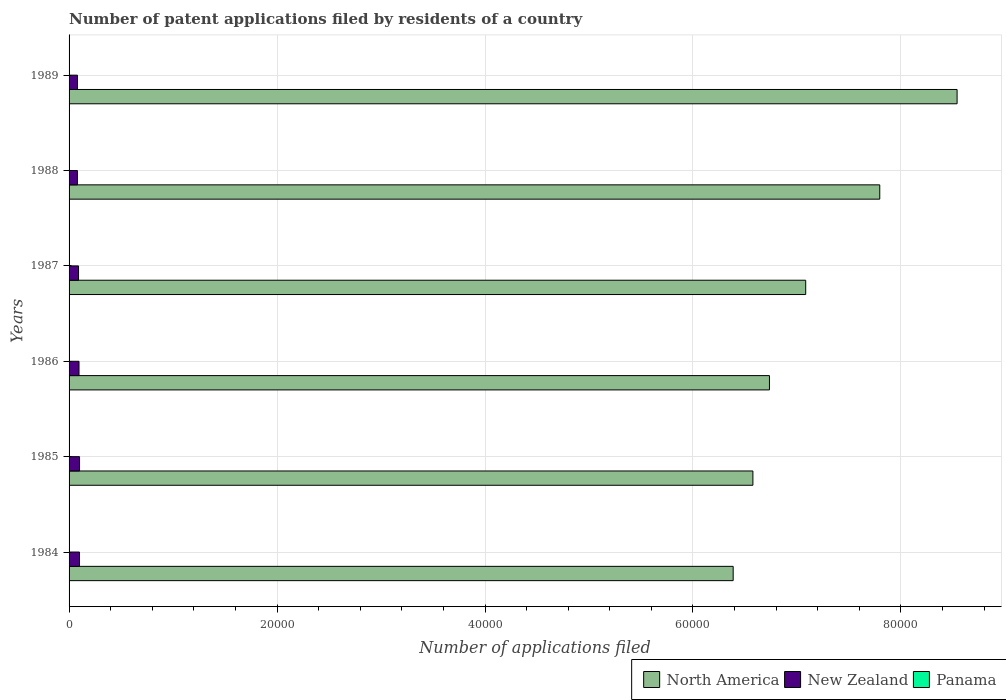Are the number of bars per tick equal to the number of legend labels?
Give a very brief answer. Yes. How many bars are there on the 5th tick from the top?
Your answer should be very brief. 3. How many bars are there on the 3rd tick from the bottom?
Provide a short and direct response. 3. What is the number of applications filed in New Zealand in 1986?
Offer a terse response. 957. Across all years, what is the maximum number of applications filed in New Zealand?
Make the answer very short. 1008. Across all years, what is the minimum number of applications filed in New Zealand?
Provide a short and direct response. 803. In which year was the number of applications filed in North America maximum?
Provide a succinct answer. 1989. In which year was the number of applications filed in North America minimum?
Keep it short and to the point. 1984. What is the total number of applications filed in North America in the graph?
Your answer should be very brief. 4.31e+05. What is the difference between the number of applications filed in North America in 1984 and that in 1986?
Your answer should be compact. -3489. What is the difference between the number of applications filed in North America in 1987 and the number of applications filed in New Zealand in 1986?
Your answer should be compact. 6.99e+04. What is the average number of applications filed in North America per year?
Provide a succinct answer. 7.19e+04. In the year 1986, what is the difference between the number of applications filed in New Zealand and number of applications filed in North America?
Offer a very short reply. -6.64e+04. What is the ratio of the number of applications filed in Panama in 1985 to that in 1988?
Make the answer very short. 1.56. Is the number of applications filed in North America in 1986 less than that in 1988?
Provide a succinct answer. Yes. Is the difference between the number of applications filed in New Zealand in 1986 and 1987 greater than the difference between the number of applications filed in North America in 1986 and 1987?
Provide a short and direct response. Yes. What is the difference between the highest and the second highest number of applications filed in New Zealand?
Keep it short and to the point. 7. What is the difference between the highest and the lowest number of applications filed in Panama?
Your response must be concise. 12. What does the 1st bar from the top in 1986 represents?
Provide a succinct answer. Panama. What does the 3rd bar from the bottom in 1988 represents?
Make the answer very short. Panama. Is it the case that in every year, the sum of the number of applications filed in New Zealand and number of applications filed in Panama is greater than the number of applications filed in North America?
Your answer should be very brief. No. How many bars are there?
Offer a terse response. 18. Are all the bars in the graph horizontal?
Your answer should be very brief. Yes. How many years are there in the graph?
Ensure brevity in your answer.  6. Does the graph contain grids?
Your response must be concise. Yes. Where does the legend appear in the graph?
Your response must be concise. Bottom right. How many legend labels are there?
Give a very brief answer. 3. What is the title of the graph?
Offer a terse response. Number of patent applications filed by residents of a country. Does "Benin" appear as one of the legend labels in the graph?
Your answer should be compact. No. What is the label or title of the X-axis?
Offer a very short reply. Number of applications filed. What is the Number of applications filed in North America in 1984?
Offer a very short reply. 6.39e+04. What is the Number of applications filed in New Zealand in 1984?
Keep it short and to the point. 1001. What is the Number of applications filed of North America in 1985?
Offer a terse response. 6.58e+04. What is the Number of applications filed in New Zealand in 1985?
Make the answer very short. 1008. What is the Number of applications filed in Panama in 1985?
Your answer should be very brief. 14. What is the Number of applications filed in North America in 1986?
Your answer should be compact. 6.74e+04. What is the Number of applications filed of New Zealand in 1986?
Offer a very short reply. 957. What is the Number of applications filed of Panama in 1986?
Offer a very short reply. 11. What is the Number of applications filed of North America in 1987?
Your answer should be compact. 7.08e+04. What is the Number of applications filed of New Zealand in 1987?
Provide a succinct answer. 912. What is the Number of applications filed in North America in 1988?
Provide a succinct answer. 7.80e+04. What is the Number of applications filed in New Zealand in 1988?
Provide a succinct answer. 803. What is the Number of applications filed of Panama in 1988?
Ensure brevity in your answer.  9. What is the Number of applications filed of North America in 1989?
Provide a short and direct response. 8.54e+04. What is the Number of applications filed of New Zealand in 1989?
Make the answer very short. 807. Across all years, what is the maximum Number of applications filed of North America?
Provide a succinct answer. 8.54e+04. Across all years, what is the maximum Number of applications filed of New Zealand?
Offer a terse response. 1008. Across all years, what is the maximum Number of applications filed in Panama?
Your answer should be compact. 15. Across all years, what is the minimum Number of applications filed in North America?
Keep it short and to the point. 6.39e+04. Across all years, what is the minimum Number of applications filed in New Zealand?
Ensure brevity in your answer.  803. Across all years, what is the minimum Number of applications filed in Panama?
Your answer should be compact. 3. What is the total Number of applications filed of North America in the graph?
Make the answer very short. 4.31e+05. What is the total Number of applications filed of New Zealand in the graph?
Your answer should be very brief. 5488. What is the total Number of applications filed of Panama in the graph?
Offer a very short reply. 58. What is the difference between the Number of applications filed in North America in 1984 and that in 1985?
Ensure brevity in your answer.  -1898. What is the difference between the Number of applications filed in New Zealand in 1984 and that in 1985?
Keep it short and to the point. -7. What is the difference between the Number of applications filed in Panama in 1984 and that in 1985?
Provide a short and direct response. 1. What is the difference between the Number of applications filed in North America in 1984 and that in 1986?
Provide a short and direct response. -3489. What is the difference between the Number of applications filed in New Zealand in 1984 and that in 1986?
Your response must be concise. 44. What is the difference between the Number of applications filed of Panama in 1984 and that in 1986?
Ensure brevity in your answer.  4. What is the difference between the Number of applications filed of North America in 1984 and that in 1987?
Your answer should be compact. -6975. What is the difference between the Number of applications filed in New Zealand in 1984 and that in 1987?
Keep it short and to the point. 89. What is the difference between the Number of applications filed in Panama in 1984 and that in 1987?
Make the answer very short. 12. What is the difference between the Number of applications filed of North America in 1984 and that in 1988?
Provide a short and direct response. -1.41e+04. What is the difference between the Number of applications filed of New Zealand in 1984 and that in 1988?
Provide a succinct answer. 198. What is the difference between the Number of applications filed in Panama in 1984 and that in 1988?
Give a very brief answer. 6. What is the difference between the Number of applications filed in North America in 1984 and that in 1989?
Your answer should be compact. -2.15e+04. What is the difference between the Number of applications filed of New Zealand in 1984 and that in 1989?
Provide a short and direct response. 194. What is the difference between the Number of applications filed of Panama in 1984 and that in 1989?
Your answer should be compact. 9. What is the difference between the Number of applications filed in North America in 1985 and that in 1986?
Keep it short and to the point. -1591. What is the difference between the Number of applications filed of New Zealand in 1985 and that in 1986?
Make the answer very short. 51. What is the difference between the Number of applications filed of North America in 1985 and that in 1987?
Your response must be concise. -5077. What is the difference between the Number of applications filed in New Zealand in 1985 and that in 1987?
Make the answer very short. 96. What is the difference between the Number of applications filed in Panama in 1985 and that in 1987?
Provide a short and direct response. 11. What is the difference between the Number of applications filed in North America in 1985 and that in 1988?
Your response must be concise. -1.22e+04. What is the difference between the Number of applications filed in New Zealand in 1985 and that in 1988?
Ensure brevity in your answer.  205. What is the difference between the Number of applications filed of North America in 1985 and that in 1989?
Your answer should be compact. -1.96e+04. What is the difference between the Number of applications filed of New Zealand in 1985 and that in 1989?
Your answer should be compact. 201. What is the difference between the Number of applications filed of North America in 1986 and that in 1987?
Ensure brevity in your answer.  -3486. What is the difference between the Number of applications filed of New Zealand in 1986 and that in 1987?
Make the answer very short. 45. What is the difference between the Number of applications filed in North America in 1986 and that in 1988?
Ensure brevity in your answer.  -1.06e+04. What is the difference between the Number of applications filed in New Zealand in 1986 and that in 1988?
Keep it short and to the point. 154. What is the difference between the Number of applications filed in Panama in 1986 and that in 1988?
Offer a terse response. 2. What is the difference between the Number of applications filed in North America in 1986 and that in 1989?
Offer a very short reply. -1.80e+04. What is the difference between the Number of applications filed of New Zealand in 1986 and that in 1989?
Your answer should be very brief. 150. What is the difference between the Number of applications filed of North America in 1987 and that in 1988?
Keep it short and to the point. -7122. What is the difference between the Number of applications filed in New Zealand in 1987 and that in 1988?
Keep it short and to the point. 109. What is the difference between the Number of applications filed in North America in 1987 and that in 1989?
Your response must be concise. -1.46e+04. What is the difference between the Number of applications filed in New Zealand in 1987 and that in 1989?
Give a very brief answer. 105. What is the difference between the Number of applications filed of Panama in 1987 and that in 1989?
Ensure brevity in your answer.  -3. What is the difference between the Number of applications filed in North America in 1988 and that in 1989?
Your answer should be compact. -7437. What is the difference between the Number of applications filed in Panama in 1988 and that in 1989?
Keep it short and to the point. 3. What is the difference between the Number of applications filed in North America in 1984 and the Number of applications filed in New Zealand in 1985?
Give a very brief answer. 6.29e+04. What is the difference between the Number of applications filed in North America in 1984 and the Number of applications filed in Panama in 1985?
Provide a succinct answer. 6.39e+04. What is the difference between the Number of applications filed of New Zealand in 1984 and the Number of applications filed of Panama in 1985?
Your response must be concise. 987. What is the difference between the Number of applications filed of North America in 1984 and the Number of applications filed of New Zealand in 1986?
Offer a very short reply. 6.29e+04. What is the difference between the Number of applications filed of North America in 1984 and the Number of applications filed of Panama in 1986?
Your answer should be compact. 6.39e+04. What is the difference between the Number of applications filed in New Zealand in 1984 and the Number of applications filed in Panama in 1986?
Give a very brief answer. 990. What is the difference between the Number of applications filed in North America in 1984 and the Number of applications filed in New Zealand in 1987?
Your answer should be compact. 6.30e+04. What is the difference between the Number of applications filed in North America in 1984 and the Number of applications filed in Panama in 1987?
Your answer should be very brief. 6.39e+04. What is the difference between the Number of applications filed of New Zealand in 1984 and the Number of applications filed of Panama in 1987?
Your answer should be very brief. 998. What is the difference between the Number of applications filed in North America in 1984 and the Number of applications filed in New Zealand in 1988?
Provide a short and direct response. 6.31e+04. What is the difference between the Number of applications filed in North America in 1984 and the Number of applications filed in Panama in 1988?
Make the answer very short. 6.39e+04. What is the difference between the Number of applications filed of New Zealand in 1984 and the Number of applications filed of Panama in 1988?
Provide a succinct answer. 992. What is the difference between the Number of applications filed of North America in 1984 and the Number of applications filed of New Zealand in 1989?
Your answer should be very brief. 6.31e+04. What is the difference between the Number of applications filed in North America in 1984 and the Number of applications filed in Panama in 1989?
Ensure brevity in your answer.  6.39e+04. What is the difference between the Number of applications filed in New Zealand in 1984 and the Number of applications filed in Panama in 1989?
Your answer should be compact. 995. What is the difference between the Number of applications filed of North America in 1985 and the Number of applications filed of New Zealand in 1986?
Keep it short and to the point. 6.48e+04. What is the difference between the Number of applications filed in North America in 1985 and the Number of applications filed in Panama in 1986?
Offer a very short reply. 6.58e+04. What is the difference between the Number of applications filed of New Zealand in 1985 and the Number of applications filed of Panama in 1986?
Make the answer very short. 997. What is the difference between the Number of applications filed of North America in 1985 and the Number of applications filed of New Zealand in 1987?
Your answer should be compact. 6.49e+04. What is the difference between the Number of applications filed in North America in 1985 and the Number of applications filed in Panama in 1987?
Provide a short and direct response. 6.58e+04. What is the difference between the Number of applications filed of New Zealand in 1985 and the Number of applications filed of Panama in 1987?
Keep it short and to the point. 1005. What is the difference between the Number of applications filed of North America in 1985 and the Number of applications filed of New Zealand in 1988?
Ensure brevity in your answer.  6.50e+04. What is the difference between the Number of applications filed of North America in 1985 and the Number of applications filed of Panama in 1988?
Offer a terse response. 6.58e+04. What is the difference between the Number of applications filed in New Zealand in 1985 and the Number of applications filed in Panama in 1988?
Provide a short and direct response. 999. What is the difference between the Number of applications filed in North America in 1985 and the Number of applications filed in New Zealand in 1989?
Ensure brevity in your answer.  6.50e+04. What is the difference between the Number of applications filed in North America in 1985 and the Number of applications filed in Panama in 1989?
Keep it short and to the point. 6.58e+04. What is the difference between the Number of applications filed of New Zealand in 1985 and the Number of applications filed of Panama in 1989?
Keep it short and to the point. 1002. What is the difference between the Number of applications filed in North America in 1986 and the Number of applications filed in New Zealand in 1987?
Provide a short and direct response. 6.64e+04. What is the difference between the Number of applications filed in North America in 1986 and the Number of applications filed in Panama in 1987?
Offer a terse response. 6.74e+04. What is the difference between the Number of applications filed in New Zealand in 1986 and the Number of applications filed in Panama in 1987?
Offer a terse response. 954. What is the difference between the Number of applications filed of North America in 1986 and the Number of applications filed of New Zealand in 1988?
Offer a very short reply. 6.66e+04. What is the difference between the Number of applications filed of North America in 1986 and the Number of applications filed of Panama in 1988?
Your answer should be compact. 6.73e+04. What is the difference between the Number of applications filed in New Zealand in 1986 and the Number of applications filed in Panama in 1988?
Provide a succinct answer. 948. What is the difference between the Number of applications filed of North America in 1986 and the Number of applications filed of New Zealand in 1989?
Give a very brief answer. 6.65e+04. What is the difference between the Number of applications filed of North America in 1986 and the Number of applications filed of Panama in 1989?
Your answer should be very brief. 6.74e+04. What is the difference between the Number of applications filed of New Zealand in 1986 and the Number of applications filed of Panama in 1989?
Make the answer very short. 951. What is the difference between the Number of applications filed in North America in 1987 and the Number of applications filed in New Zealand in 1988?
Your answer should be very brief. 7.00e+04. What is the difference between the Number of applications filed of North America in 1987 and the Number of applications filed of Panama in 1988?
Provide a succinct answer. 7.08e+04. What is the difference between the Number of applications filed of New Zealand in 1987 and the Number of applications filed of Panama in 1988?
Provide a succinct answer. 903. What is the difference between the Number of applications filed in North America in 1987 and the Number of applications filed in New Zealand in 1989?
Your response must be concise. 7.00e+04. What is the difference between the Number of applications filed of North America in 1987 and the Number of applications filed of Panama in 1989?
Offer a terse response. 7.08e+04. What is the difference between the Number of applications filed in New Zealand in 1987 and the Number of applications filed in Panama in 1989?
Your answer should be very brief. 906. What is the difference between the Number of applications filed in North America in 1988 and the Number of applications filed in New Zealand in 1989?
Give a very brief answer. 7.72e+04. What is the difference between the Number of applications filed in North America in 1988 and the Number of applications filed in Panama in 1989?
Your response must be concise. 7.80e+04. What is the difference between the Number of applications filed of New Zealand in 1988 and the Number of applications filed of Panama in 1989?
Provide a succinct answer. 797. What is the average Number of applications filed of North America per year?
Make the answer very short. 7.19e+04. What is the average Number of applications filed in New Zealand per year?
Give a very brief answer. 914.67. What is the average Number of applications filed in Panama per year?
Keep it short and to the point. 9.67. In the year 1984, what is the difference between the Number of applications filed of North America and Number of applications filed of New Zealand?
Provide a succinct answer. 6.29e+04. In the year 1984, what is the difference between the Number of applications filed in North America and Number of applications filed in Panama?
Give a very brief answer. 6.39e+04. In the year 1984, what is the difference between the Number of applications filed in New Zealand and Number of applications filed in Panama?
Your response must be concise. 986. In the year 1985, what is the difference between the Number of applications filed of North America and Number of applications filed of New Zealand?
Provide a short and direct response. 6.48e+04. In the year 1985, what is the difference between the Number of applications filed in North America and Number of applications filed in Panama?
Offer a terse response. 6.58e+04. In the year 1985, what is the difference between the Number of applications filed in New Zealand and Number of applications filed in Panama?
Give a very brief answer. 994. In the year 1986, what is the difference between the Number of applications filed in North America and Number of applications filed in New Zealand?
Your response must be concise. 6.64e+04. In the year 1986, what is the difference between the Number of applications filed in North America and Number of applications filed in Panama?
Provide a short and direct response. 6.73e+04. In the year 1986, what is the difference between the Number of applications filed in New Zealand and Number of applications filed in Panama?
Your answer should be compact. 946. In the year 1987, what is the difference between the Number of applications filed of North America and Number of applications filed of New Zealand?
Make the answer very short. 6.99e+04. In the year 1987, what is the difference between the Number of applications filed of North America and Number of applications filed of Panama?
Offer a very short reply. 7.08e+04. In the year 1987, what is the difference between the Number of applications filed in New Zealand and Number of applications filed in Panama?
Provide a short and direct response. 909. In the year 1988, what is the difference between the Number of applications filed in North America and Number of applications filed in New Zealand?
Give a very brief answer. 7.72e+04. In the year 1988, what is the difference between the Number of applications filed in North America and Number of applications filed in Panama?
Provide a short and direct response. 7.80e+04. In the year 1988, what is the difference between the Number of applications filed of New Zealand and Number of applications filed of Panama?
Your answer should be very brief. 794. In the year 1989, what is the difference between the Number of applications filed in North America and Number of applications filed in New Zealand?
Give a very brief answer. 8.46e+04. In the year 1989, what is the difference between the Number of applications filed of North America and Number of applications filed of Panama?
Provide a succinct answer. 8.54e+04. In the year 1989, what is the difference between the Number of applications filed in New Zealand and Number of applications filed in Panama?
Offer a very short reply. 801. What is the ratio of the Number of applications filed of North America in 1984 to that in 1985?
Provide a succinct answer. 0.97. What is the ratio of the Number of applications filed in New Zealand in 1984 to that in 1985?
Provide a short and direct response. 0.99. What is the ratio of the Number of applications filed in Panama in 1984 to that in 1985?
Your answer should be very brief. 1.07. What is the ratio of the Number of applications filed of North America in 1984 to that in 1986?
Keep it short and to the point. 0.95. What is the ratio of the Number of applications filed of New Zealand in 1984 to that in 1986?
Give a very brief answer. 1.05. What is the ratio of the Number of applications filed of Panama in 1984 to that in 1986?
Your response must be concise. 1.36. What is the ratio of the Number of applications filed of North America in 1984 to that in 1987?
Provide a short and direct response. 0.9. What is the ratio of the Number of applications filed in New Zealand in 1984 to that in 1987?
Provide a succinct answer. 1.1. What is the ratio of the Number of applications filed in Panama in 1984 to that in 1987?
Ensure brevity in your answer.  5. What is the ratio of the Number of applications filed in North America in 1984 to that in 1988?
Keep it short and to the point. 0.82. What is the ratio of the Number of applications filed in New Zealand in 1984 to that in 1988?
Offer a very short reply. 1.25. What is the ratio of the Number of applications filed in North America in 1984 to that in 1989?
Make the answer very short. 0.75. What is the ratio of the Number of applications filed in New Zealand in 1984 to that in 1989?
Your response must be concise. 1.24. What is the ratio of the Number of applications filed in Panama in 1984 to that in 1989?
Provide a succinct answer. 2.5. What is the ratio of the Number of applications filed of North America in 1985 to that in 1986?
Your answer should be very brief. 0.98. What is the ratio of the Number of applications filed of New Zealand in 1985 to that in 1986?
Offer a very short reply. 1.05. What is the ratio of the Number of applications filed in Panama in 1985 to that in 1986?
Make the answer very short. 1.27. What is the ratio of the Number of applications filed in North America in 1985 to that in 1987?
Provide a succinct answer. 0.93. What is the ratio of the Number of applications filed in New Zealand in 1985 to that in 1987?
Offer a very short reply. 1.11. What is the ratio of the Number of applications filed in Panama in 1985 to that in 1987?
Provide a short and direct response. 4.67. What is the ratio of the Number of applications filed in North America in 1985 to that in 1988?
Keep it short and to the point. 0.84. What is the ratio of the Number of applications filed of New Zealand in 1985 to that in 1988?
Give a very brief answer. 1.26. What is the ratio of the Number of applications filed in Panama in 1985 to that in 1988?
Offer a very short reply. 1.56. What is the ratio of the Number of applications filed of North America in 1985 to that in 1989?
Provide a short and direct response. 0.77. What is the ratio of the Number of applications filed of New Zealand in 1985 to that in 1989?
Provide a succinct answer. 1.25. What is the ratio of the Number of applications filed of Panama in 1985 to that in 1989?
Keep it short and to the point. 2.33. What is the ratio of the Number of applications filed of North America in 1986 to that in 1987?
Your answer should be compact. 0.95. What is the ratio of the Number of applications filed in New Zealand in 1986 to that in 1987?
Your response must be concise. 1.05. What is the ratio of the Number of applications filed of Panama in 1986 to that in 1987?
Give a very brief answer. 3.67. What is the ratio of the Number of applications filed in North America in 1986 to that in 1988?
Keep it short and to the point. 0.86. What is the ratio of the Number of applications filed in New Zealand in 1986 to that in 1988?
Your answer should be very brief. 1.19. What is the ratio of the Number of applications filed of Panama in 1986 to that in 1988?
Your answer should be compact. 1.22. What is the ratio of the Number of applications filed in North America in 1986 to that in 1989?
Your response must be concise. 0.79. What is the ratio of the Number of applications filed in New Zealand in 1986 to that in 1989?
Make the answer very short. 1.19. What is the ratio of the Number of applications filed in Panama in 1986 to that in 1989?
Your answer should be very brief. 1.83. What is the ratio of the Number of applications filed in North America in 1987 to that in 1988?
Keep it short and to the point. 0.91. What is the ratio of the Number of applications filed of New Zealand in 1987 to that in 1988?
Your response must be concise. 1.14. What is the ratio of the Number of applications filed of Panama in 1987 to that in 1988?
Your response must be concise. 0.33. What is the ratio of the Number of applications filed in North America in 1987 to that in 1989?
Your response must be concise. 0.83. What is the ratio of the Number of applications filed of New Zealand in 1987 to that in 1989?
Give a very brief answer. 1.13. What is the ratio of the Number of applications filed in Panama in 1987 to that in 1989?
Provide a short and direct response. 0.5. What is the ratio of the Number of applications filed of North America in 1988 to that in 1989?
Give a very brief answer. 0.91. What is the ratio of the Number of applications filed of New Zealand in 1988 to that in 1989?
Ensure brevity in your answer.  0.99. What is the ratio of the Number of applications filed in Panama in 1988 to that in 1989?
Offer a terse response. 1.5. What is the difference between the highest and the second highest Number of applications filed in North America?
Ensure brevity in your answer.  7437. What is the difference between the highest and the lowest Number of applications filed in North America?
Ensure brevity in your answer.  2.15e+04. What is the difference between the highest and the lowest Number of applications filed in New Zealand?
Your answer should be compact. 205. What is the difference between the highest and the lowest Number of applications filed of Panama?
Your answer should be very brief. 12. 